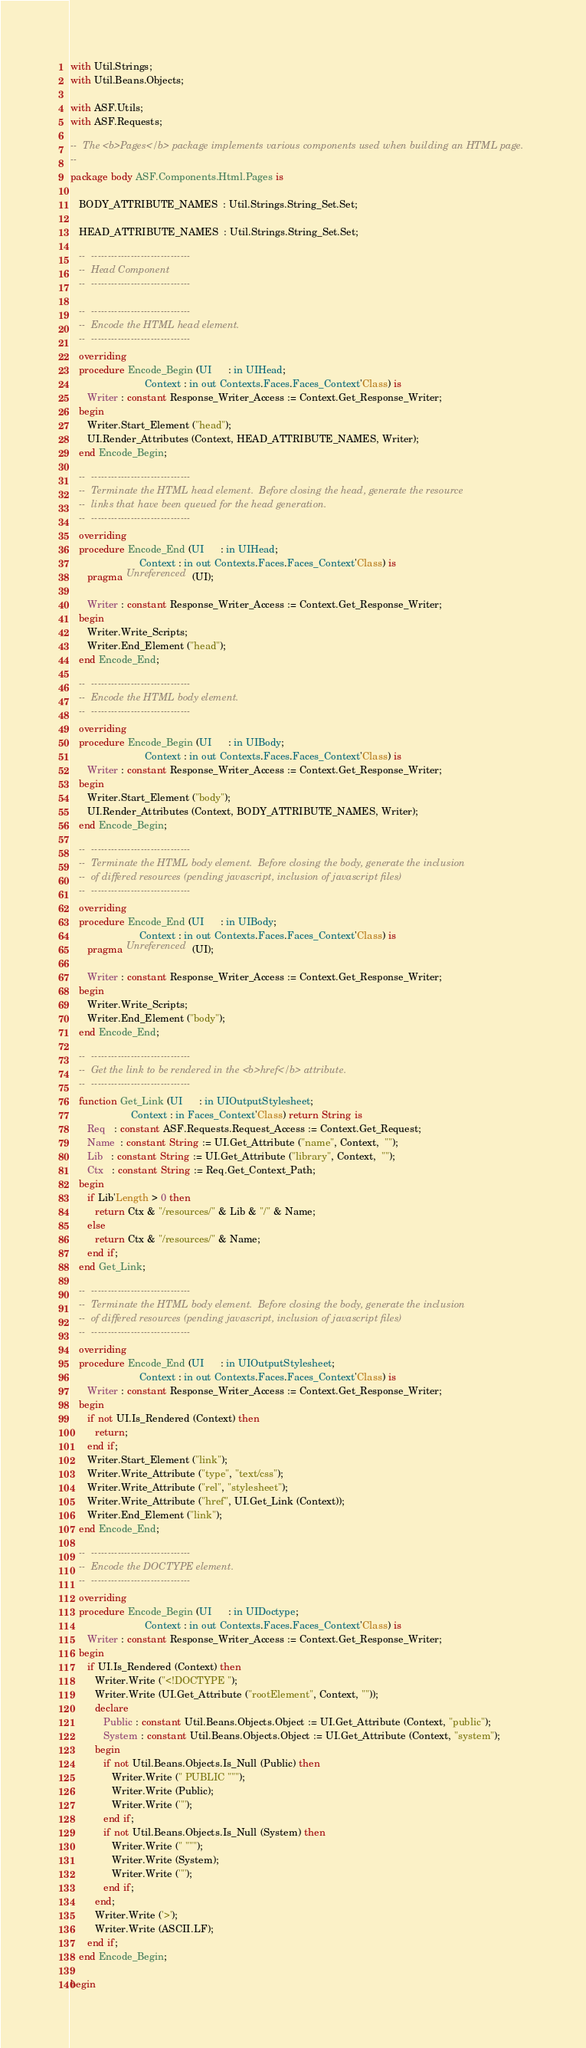<code> <loc_0><loc_0><loc_500><loc_500><_Ada_>
with Util.Strings;
with Util.Beans.Objects;

with ASF.Utils;
with ASF.Requests;

--  The <b>Pages</b> package implements various components used when building an HTML page.
--
package body ASF.Components.Html.Pages is

   BODY_ATTRIBUTE_NAMES  : Util.Strings.String_Set.Set;

   HEAD_ATTRIBUTE_NAMES  : Util.Strings.String_Set.Set;

   --  ------------------------------
   --  Head Component
   --  ------------------------------

   --  ------------------------------
   --  Encode the HTML head element.
   --  ------------------------------
   overriding
   procedure Encode_Begin (UI      : in UIHead;
                           Context : in out Contexts.Faces.Faces_Context'Class) is
      Writer : constant Response_Writer_Access := Context.Get_Response_Writer;
   begin
      Writer.Start_Element ("head");
      UI.Render_Attributes (Context, HEAD_ATTRIBUTE_NAMES, Writer);
   end Encode_Begin;

   --  ------------------------------
   --  Terminate the HTML head element.  Before closing the head, generate the resource
   --  links that have been queued for the head generation.
   --  ------------------------------
   overriding
   procedure Encode_End (UI      : in UIHead;
                         Context : in out Contexts.Faces.Faces_Context'Class) is
      pragma Unreferenced (UI);

      Writer : constant Response_Writer_Access := Context.Get_Response_Writer;
   begin
      Writer.Write_Scripts;
      Writer.End_Element ("head");
   end Encode_End;

   --  ------------------------------
   --  Encode the HTML body element.
   --  ------------------------------
   overriding
   procedure Encode_Begin (UI      : in UIBody;
                           Context : in out Contexts.Faces.Faces_Context'Class) is
      Writer : constant Response_Writer_Access := Context.Get_Response_Writer;
   begin
      Writer.Start_Element ("body");
      UI.Render_Attributes (Context, BODY_ATTRIBUTE_NAMES, Writer);
   end Encode_Begin;

   --  ------------------------------
   --  Terminate the HTML body element.  Before closing the body, generate the inclusion
   --  of differed resources (pending javascript, inclusion of javascript files)
   --  ------------------------------
   overriding
   procedure Encode_End (UI      : in UIBody;
                         Context : in out Contexts.Faces.Faces_Context'Class) is
      pragma Unreferenced (UI);

      Writer : constant Response_Writer_Access := Context.Get_Response_Writer;
   begin
      Writer.Write_Scripts;
      Writer.End_Element ("body");
   end Encode_End;

   --  ------------------------------
   --  Get the link to be rendered in the <b>href</b> attribute.
   --  ------------------------------
   function Get_Link (UI      : in UIOutputStylesheet;
                      Context : in Faces_Context'Class) return String is
      Req   : constant ASF.Requests.Request_Access := Context.Get_Request;
      Name  : constant String := UI.Get_Attribute ("name", Context,  "");
      Lib   : constant String := UI.Get_Attribute ("library", Context,  "");
      Ctx   : constant String := Req.Get_Context_Path;
   begin
      if Lib'Length > 0 then
         return Ctx & "/resources/" & Lib & "/" & Name;
      else
         return Ctx & "/resources/" & Name;
      end if;
   end Get_Link;

   --  ------------------------------
   --  Terminate the HTML body element.  Before closing the body, generate the inclusion
   --  of differed resources (pending javascript, inclusion of javascript files)
   --  ------------------------------
   overriding
   procedure Encode_End (UI      : in UIOutputStylesheet;
                         Context : in out Contexts.Faces.Faces_Context'Class) is
      Writer : constant Response_Writer_Access := Context.Get_Response_Writer;
   begin
      if not UI.Is_Rendered (Context) then
         return;
      end if;
      Writer.Start_Element ("link");
      Writer.Write_Attribute ("type", "text/css");
      Writer.Write_Attribute ("rel", "stylesheet");
      Writer.Write_Attribute ("href", UI.Get_Link (Context));
      Writer.End_Element ("link");
   end Encode_End;

   --  ------------------------------
   --  Encode the DOCTYPE element.
   --  ------------------------------
   overriding
   procedure Encode_Begin (UI      : in UIDoctype;
                           Context : in out Contexts.Faces.Faces_Context'Class) is
      Writer : constant Response_Writer_Access := Context.Get_Response_Writer;
   begin
      if UI.Is_Rendered (Context) then
         Writer.Write ("<!DOCTYPE ");
         Writer.Write (UI.Get_Attribute ("rootElement", Context, ""));
         declare
            Public : constant Util.Beans.Objects.Object := UI.Get_Attribute (Context, "public");
            System : constant Util.Beans.Objects.Object := UI.Get_Attribute (Context, "system");
         begin
            if not Util.Beans.Objects.Is_Null (Public) then
               Writer.Write (" PUBLIC """);
               Writer.Write (Public);
               Writer.Write ('"');
            end if;
            if not Util.Beans.Objects.Is_Null (System) then
               Writer.Write (" """);
               Writer.Write (System);
               Writer.Write ('"');
            end if;
         end;
         Writer.Write ('>');
         Writer.Write (ASCII.LF);
      end if;
   end Encode_Begin;

begin</code> 